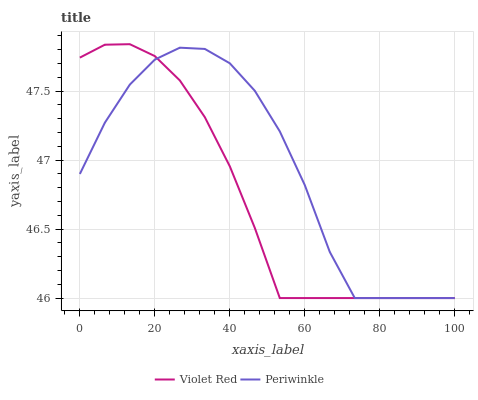Does Periwinkle have the minimum area under the curve?
Answer yes or no. No. Is Periwinkle the smoothest?
Answer yes or no. No. Does Periwinkle have the highest value?
Answer yes or no. No. 